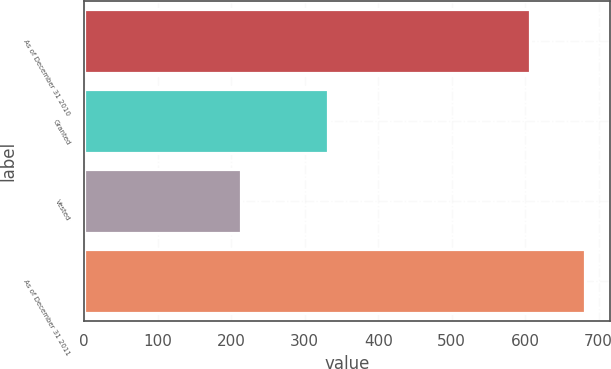<chart> <loc_0><loc_0><loc_500><loc_500><bar_chart><fcel>As of December 31 2010<fcel>Granted<fcel>Vested<fcel>As of December 31 2011<nl><fcel>607<fcel>332<fcel>213<fcel>682<nl></chart> 